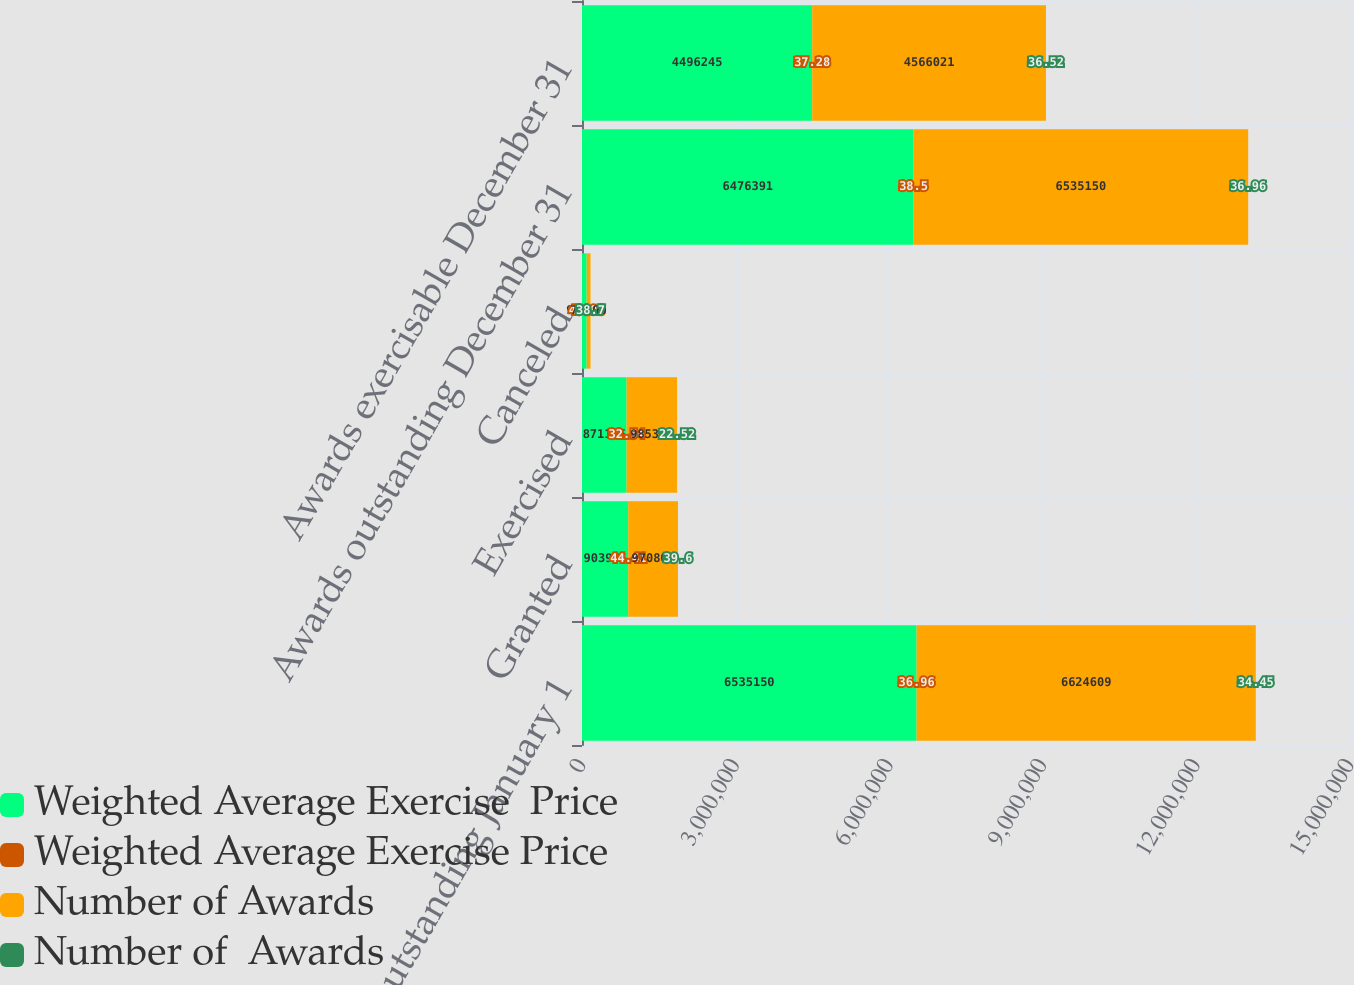Convert chart to OTSL. <chart><loc_0><loc_0><loc_500><loc_500><stacked_bar_chart><ecel><fcel>Awards outstanding January 1<fcel>Granted<fcel>Exercised<fcel>Canceled<fcel>Awards outstanding December 31<fcel>Awards exercisable December 31<nl><fcel>Weighted Average Exercise  Price<fcel>6.53515e+06<fcel>903975<fcel>871155<fcel>91579<fcel>6.47639e+06<fcel>4.49624e+06<nl><fcel>Weighted Average Exercise Price<fcel>36.96<fcel>44.41<fcel>32.54<fcel>43.98<fcel>38.5<fcel>37.28<nl><fcel>Number of Awards<fcel>6.62461e+06<fcel>970800<fcel>985359<fcel>74900<fcel>6.53515e+06<fcel>4.56602e+06<nl><fcel>Number of  Awards<fcel>34.45<fcel>39.6<fcel>22.52<fcel>38.7<fcel>36.96<fcel>36.52<nl></chart> 